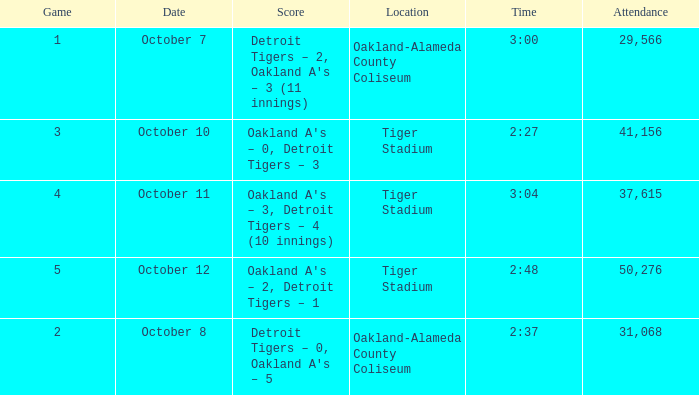What is the number of people in attendance when the time is 3:00? 29566.0. 